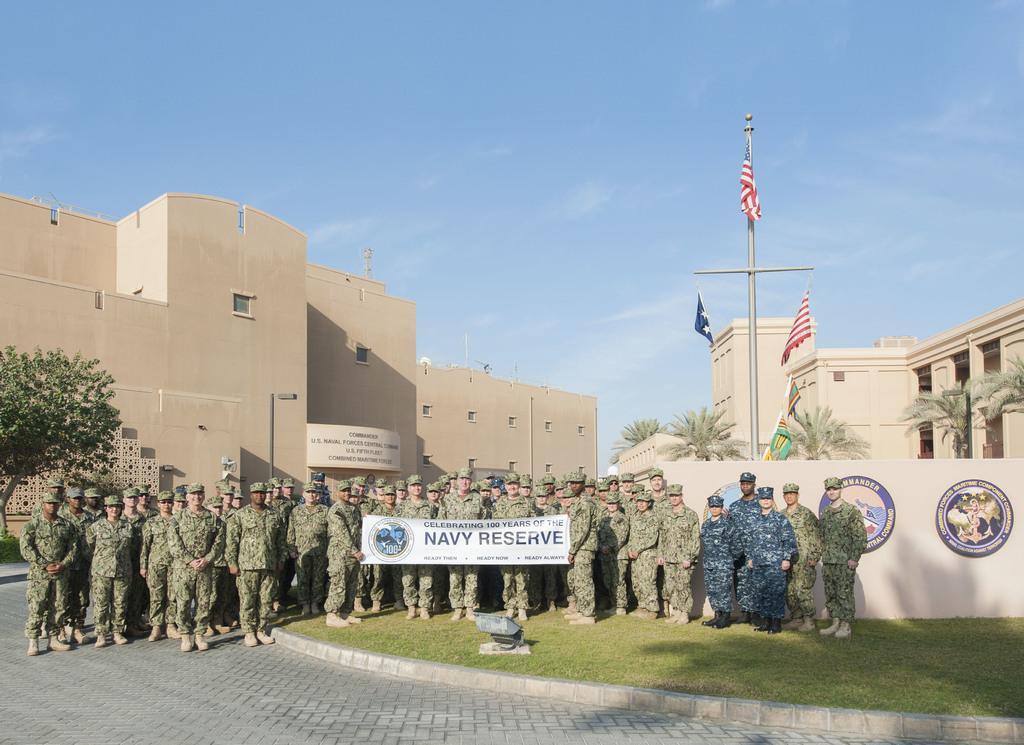How would you summarize this image in a sentence or two? In this picture we can see group of people and they are holding a banner. This is grass. In the background we can see buildings, trees, pole, flags, boards, and sky. 